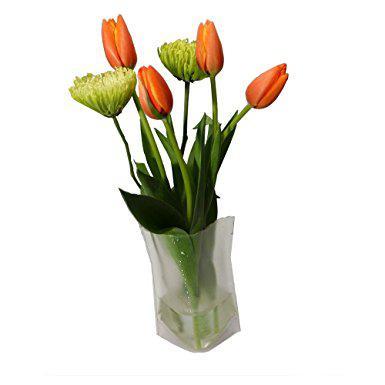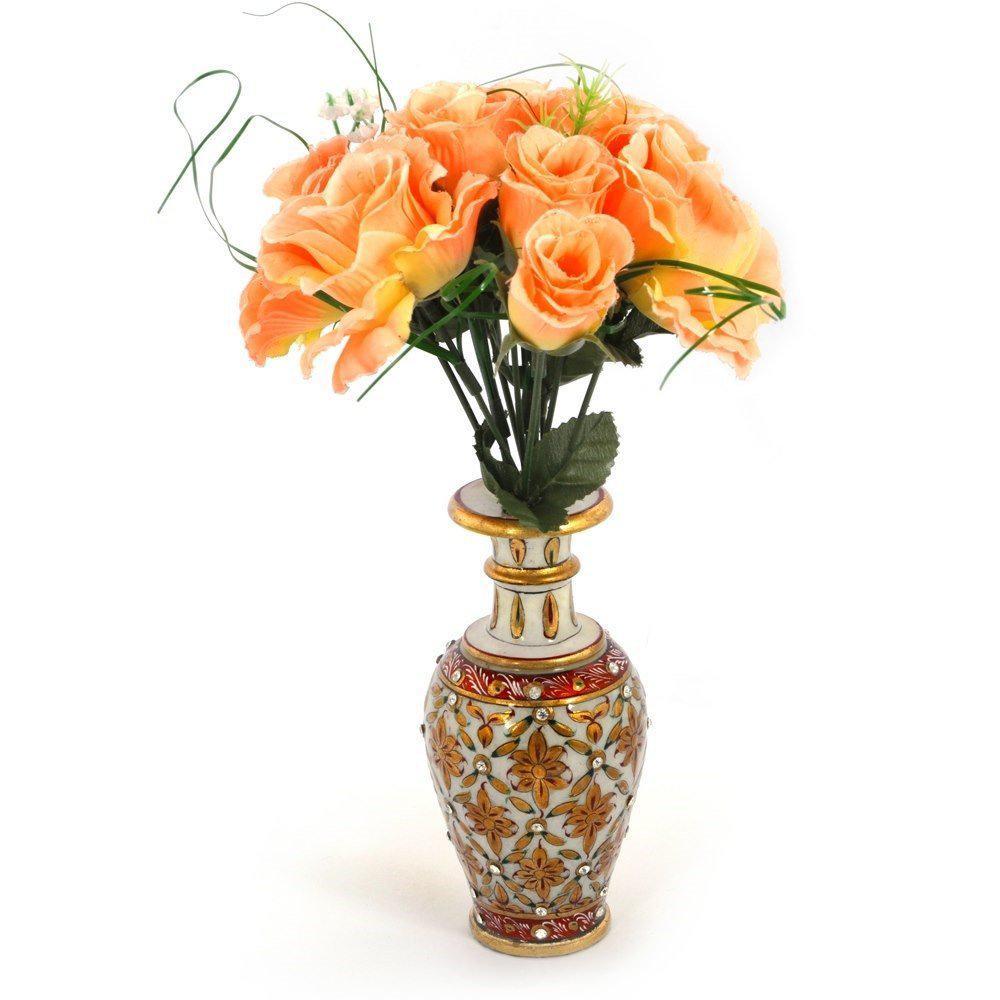The first image is the image on the left, the second image is the image on the right. Given the left and right images, does the statement "One of the images contains at least one vase that is completely opaque." hold true? Answer yes or no. Yes. 